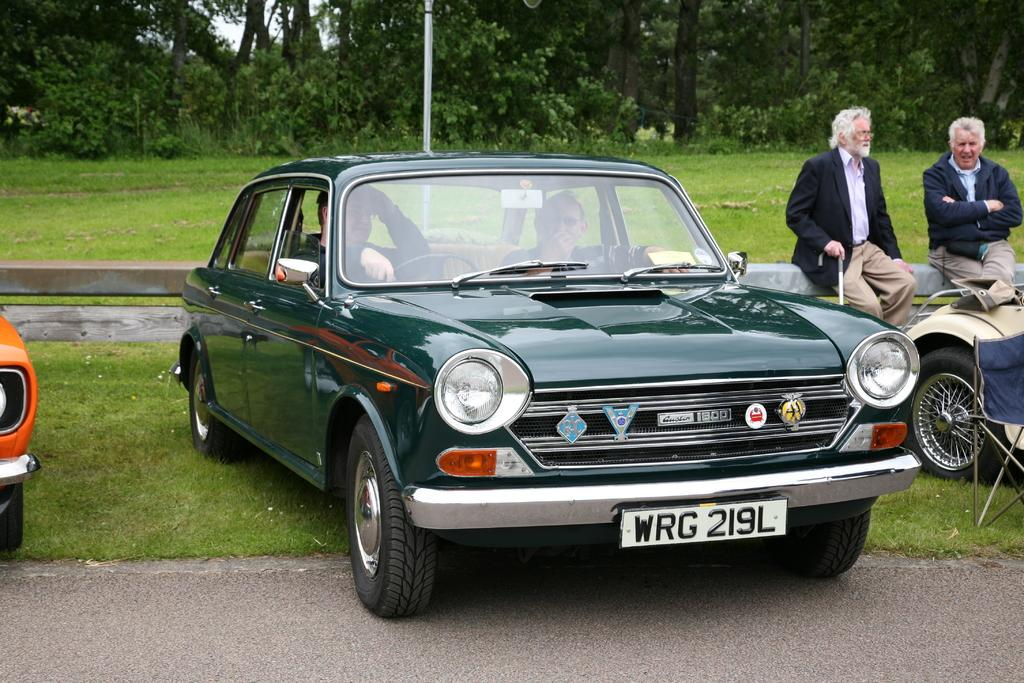What is the main subject of the image? The main subject of the image is a car on the road. Can you describe the car's occupant? There is a person sitting in the car. What type of natural environment is visible in the image? There is grass visible in the image. What can be seen in the background of the image? There are trees in the background of the image. How many matches are visible in the image? There are no matches present in the image. What type of coastline can be seen in the image? There is no coastline visible in the image; it features a car on the road with trees in the background. 